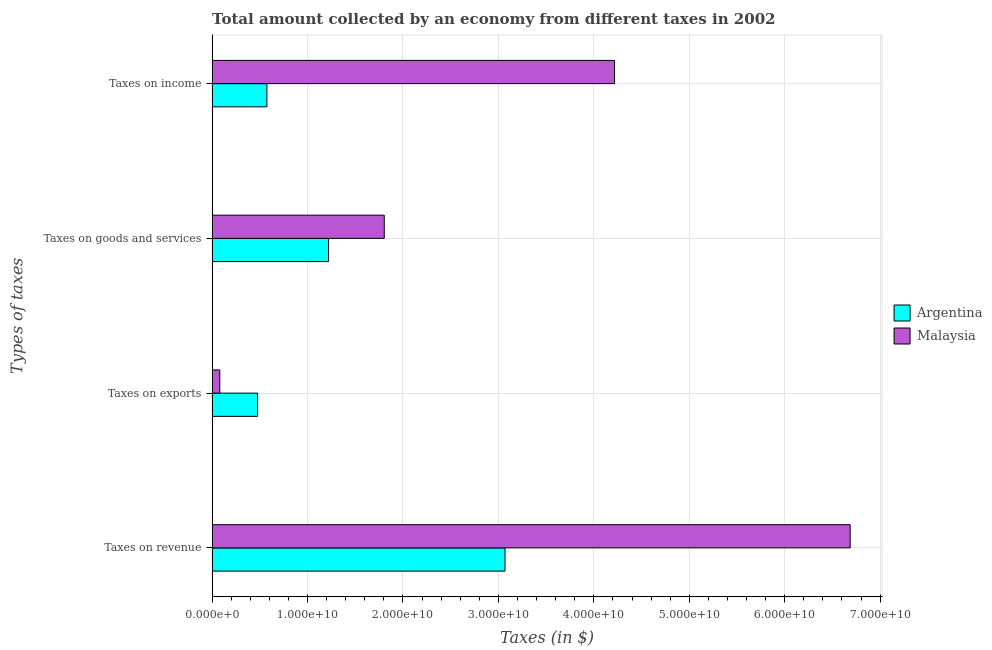Are the number of bars on each tick of the Y-axis equal?
Your answer should be compact. Yes. How many bars are there on the 3rd tick from the bottom?
Offer a very short reply. 2. What is the label of the 3rd group of bars from the top?
Ensure brevity in your answer.  Taxes on exports. What is the amount collected as tax on exports in Malaysia?
Provide a succinct answer. 8.03e+08. Across all countries, what is the maximum amount collected as tax on income?
Offer a terse response. 4.22e+1. Across all countries, what is the minimum amount collected as tax on exports?
Keep it short and to the point. 8.03e+08. What is the total amount collected as tax on exports in the graph?
Your answer should be very brief. 5.56e+09. What is the difference between the amount collected as tax on revenue in Malaysia and that in Argentina?
Offer a very short reply. 3.62e+1. What is the difference between the amount collected as tax on income in Malaysia and the amount collected as tax on revenue in Argentina?
Provide a succinct answer. 1.15e+1. What is the average amount collected as tax on exports per country?
Provide a succinct answer. 2.78e+09. What is the difference between the amount collected as tax on income and amount collected as tax on exports in Argentina?
Your answer should be very brief. 9.82e+08. What is the ratio of the amount collected as tax on income in Malaysia to that in Argentina?
Offer a very short reply. 7.35. Is the difference between the amount collected as tax on revenue in Argentina and Malaysia greater than the difference between the amount collected as tax on income in Argentina and Malaysia?
Your response must be concise. Yes. What is the difference between the highest and the second highest amount collected as tax on exports?
Give a very brief answer. 3.95e+09. What is the difference between the highest and the lowest amount collected as tax on income?
Ensure brevity in your answer.  3.64e+1. What does the 1st bar from the top in Taxes on exports represents?
Keep it short and to the point. Malaysia. What does the 2nd bar from the bottom in Taxes on income represents?
Give a very brief answer. Malaysia. Are all the bars in the graph horizontal?
Keep it short and to the point. Yes. Are the values on the major ticks of X-axis written in scientific E-notation?
Your answer should be very brief. Yes. Does the graph contain any zero values?
Keep it short and to the point. No. Where does the legend appear in the graph?
Provide a short and direct response. Center right. What is the title of the graph?
Provide a short and direct response. Total amount collected by an economy from different taxes in 2002. What is the label or title of the X-axis?
Provide a short and direct response. Taxes (in $). What is the label or title of the Y-axis?
Your response must be concise. Types of taxes. What is the Taxes (in $) of Argentina in Taxes on revenue?
Give a very brief answer. 3.07e+1. What is the Taxes (in $) of Malaysia in Taxes on revenue?
Provide a short and direct response. 6.69e+1. What is the Taxes (in $) in Argentina in Taxes on exports?
Your answer should be very brief. 4.76e+09. What is the Taxes (in $) in Malaysia in Taxes on exports?
Ensure brevity in your answer.  8.03e+08. What is the Taxes (in $) of Argentina in Taxes on goods and services?
Give a very brief answer. 1.22e+1. What is the Taxes (in $) of Malaysia in Taxes on goods and services?
Your answer should be very brief. 1.80e+1. What is the Taxes (in $) in Argentina in Taxes on income?
Offer a very short reply. 5.74e+09. What is the Taxes (in $) of Malaysia in Taxes on income?
Offer a terse response. 4.22e+1. Across all Types of taxes, what is the maximum Taxes (in $) in Argentina?
Provide a short and direct response. 3.07e+1. Across all Types of taxes, what is the maximum Taxes (in $) of Malaysia?
Offer a very short reply. 6.69e+1. Across all Types of taxes, what is the minimum Taxes (in $) of Argentina?
Offer a very short reply. 4.76e+09. Across all Types of taxes, what is the minimum Taxes (in $) in Malaysia?
Give a very brief answer. 8.03e+08. What is the total Taxes (in $) of Argentina in the graph?
Ensure brevity in your answer.  5.34e+1. What is the total Taxes (in $) of Malaysia in the graph?
Provide a succinct answer. 1.28e+11. What is the difference between the Taxes (in $) in Argentina in Taxes on revenue and that in Taxes on exports?
Provide a succinct answer. 2.59e+1. What is the difference between the Taxes (in $) of Malaysia in Taxes on revenue and that in Taxes on exports?
Your answer should be compact. 6.61e+1. What is the difference between the Taxes (in $) in Argentina in Taxes on revenue and that in Taxes on goods and services?
Offer a terse response. 1.85e+1. What is the difference between the Taxes (in $) of Malaysia in Taxes on revenue and that in Taxes on goods and services?
Your answer should be compact. 4.88e+1. What is the difference between the Taxes (in $) in Argentina in Taxes on revenue and that in Taxes on income?
Make the answer very short. 2.50e+1. What is the difference between the Taxes (in $) of Malaysia in Taxes on revenue and that in Taxes on income?
Your answer should be very brief. 2.47e+1. What is the difference between the Taxes (in $) in Argentina in Taxes on exports and that in Taxes on goods and services?
Your answer should be compact. -7.44e+09. What is the difference between the Taxes (in $) of Malaysia in Taxes on exports and that in Taxes on goods and services?
Provide a short and direct response. -1.72e+1. What is the difference between the Taxes (in $) in Argentina in Taxes on exports and that in Taxes on income?
Your answer should be very brief. -9.82e+08. What is the difference between the Taxes (in $) of Malaysia in Taxes on exports and that in Taxes on income?
Ensure brevity in your answer.  -4.14e+1. What is the difference between the Taxes (in $) in Argentina in Taxes on goods and services and that in Taxes on income?
Offer a very short reply. 6.46e+09. What is the difference between the Taxes (in $) of Malaysia in Taxes on goods and services and that in Taxes on income?
Your response must be concise. -2.41e+1. What is the difference between the Taxes (in $) in Argentina in Taxes on revenue and the Taxes (in $) in Malaysia in Taxes on exports?
Make the answer very short. 2.99e+1. What is the difference between the Taxes (in $) in Argentina in Taxes on revenue and the Taxes (in $) in Malaysia in Taxes on goods and services?
Provide a succinct answer. 1.27e+1. What is the difference between the Taxes (in $) in Argentina in Taxes on revenue and the Taxes (in $) in Malaysia in Taxes on income?
Your response must be concise. -1.15e+1. What is the difference between the Taxes (in $) of Argentina in Taxes on exports and the Taxes (in $) of Malaysia in Taxes on goods and services?
Give a very brief answer. -1.33e+1. What is the difference between the Taxes (in $) in Argentina in Taxes on exports and the Taxes (in $) in Malaysia in Taxes on income?
Keep it short and to the point. -3.74e+1. What is the difference between the Taxes (in $) in Argentina in Taxes on goods and services and the Taxes (in $) in Malaysia in Taxes on income?
Give a very brief answer. -3.00e+1. What is the average Taxes (in $) of Argentina per Types of taxes?
Your answer should be compact. 1.33e+1. What is the average Taxes (in $) of Malaysia per Types of taxes?
Your response must be concise. 3.20e+1. What is the difference between the Taxes (in $) in Argentina and Taxes (in $) in Malaysia in Taxes on revenue?
Ensure brevity in your answer.  -3.62e+1. What is the difference between the Taxes (in $) in Argentina and Taxes (in $) in Malaysia in Taxes on exports?
Make the answer very short. 3.95e+09. What is the difference between the Taxes (in $) of Argentina and Taxes (in $) of Malaysia in Taxes on goods and services?
Give a very brief answer. -5.84e+09. What is the difference between the Taxes (in $) of Argentina and Taxes (in $) of Malaysia in Taxes on income?
Provide a short and direct response. -3.64e+1. What is the ratio of the Taxes (in $) in Argentina in Taxes on revenue to that in Taxes on exports?
Provide a succinct answer. 6.45. What is the ratio of the Taxes (in $) of Malaysia in Taxes on revenue to that in Taxes on exports?
Provide a short and direct response. 83.26. What is the ratio of the Taxes (in $) in Argentina in Taxes on revenue to that in Taxes on goods and services?
Your answer should be compact. 2.52. What is the ratio of the Taxes (in $) in Malaysia in Taxes on revenue to that in Taxes on goods and services?
Make the answer very short. 3.71. What is the ratio of the Taxes (in $) in Argentina in Taxes on revenue to that in Taxes on income?
Offer a terse response. 5.35. What is the ratio of the Taxes (in $) in Malaysia in Taxes on revenue to that in Taxes on income?
Provide a succinct answer. 1.59. What is the ratio of the Taxes (in $) in Argentina in Taxes on exports to that in Taxes on goods and services?
Provide a short and direct response. 0.39. What is the ratio of the Taxes (in $) in Malaysia in Taxes on exports to that in Taxes on goods and services?
Keep it short and to the point. 0.04. What is the ratio of the Taxes (in $) in Argentina in Taxes on exports to that in Taxes on income?
Ensure brevity in your answer.  0.83. What is the ratio of the Taxes (in $) of Malaysia in Taxes on exports to that in Taxes on income?
Your response must be concise. 0.02. What is the ratio of the Taxes (in $) in Argentina in Taxes on goods and services to that in Taxes on income?
Offer a very short reply. 2.13. What is the ratio of the Taxes (in $) of Malaysia in Taxes on goods and services to that in Taxes on income?
Provide a succinct answer. 0.43. What is the difference between the highest and the second highest Taxes (in $) in Argentina?
Keep it short and to the point. 1.85e+1. What is the difference between the highest and the second highest Taxes (in $) of Malaysia?
Ensure brevity in your answer.  2.47e+1. What is the difference between the highest and the lowest Taxes (in $) of Argentina?
Ensure brevity in your answer.  2.59e+1. What is the difference between the highest and the lowest Taxes (in $) of Malaysia?
Your answer should be compact. 6.61e+1. 